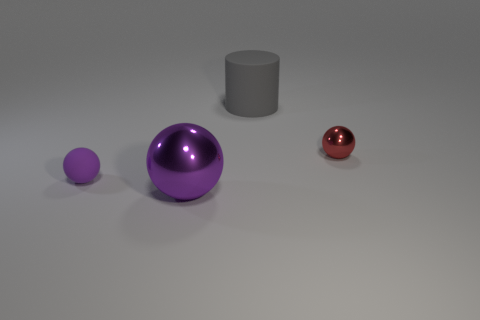How many big things are purple shiny cylinders or gray things?
Provide a succinct answer. 1. There is a object that is both on the right side of the large purple metal object and in front of the large gray cylinder; what is its shape?
Your response must be concise. Sphere. Is the material of the tiny red thing the same as the big gray thing?
Offer a very short reply. No. What color is the thing that is the same size as the purple matte ball?
Offer a very short reply. Red. There is a sphere that is behind the large purple metallic thing and right of the tiny purple matte thing; what color is it?
Give a very brief answer. Red. What size is the metallic ball that is the same color as the small rubber ball?
Your answer should be very brief. Large. What is the shape of the object that is the same color as the large ball?
Your response must be concise. Sphere. There is a sphere that is left of the shiny sphere that is in front of the metal ball behind the small rubber object; what is its size?
Keep it short and to the point. Small. What is the material of the small red sphere?
Ensure brevity in your answer.  Metal. Is the big gray cylinder made of the same material as the big thing that is in front of the tiny metallic ball?
Make the answer very short. No. 